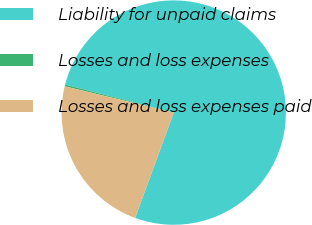Convert chart to OTSL. <chart><loc_0><loc_0><loc_500><loc_500><pie_chart><fcel>Liability for unpaid claims<fcel>Losses and loss expenses<fcel>Losses and loss expenses paid<nl><fcel>76.57%<fcel>0.26%<fcel>23.17%<nl></chart> 